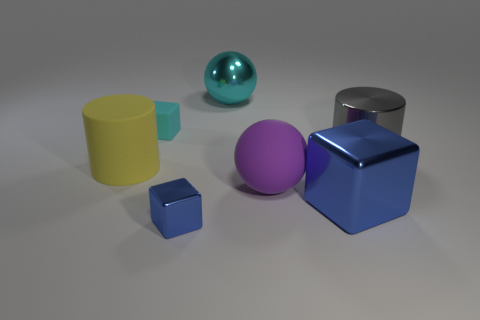What is the shape of the large blue metallic thing?
Your response must be concise. Cube. There is a small blue cube that is in front of the big cylinder that is to the left of the large ball that is on the right side of the big cyan metal object; what is it made of?
Offer a terse response. Metal. Are there more large spheres that are behind the yellow thing than large metallic cylinders?
Offer a terse response. No. What material is the cyan thing that is the same size as the purple sphere?
Offer a terse response. Metal. Are there any cylinders of the same size as the purple ball?
Make the answer very short. Yes. What is the size of the matte object that is behind the gray metallic thing?
Provide a succinct answer. Small. What is the size of the gray thing?
Offer a terse response. Large. How many blocks are tiny gray rubber things or cyan metallic things?
Your answer should be very brief. 0. What is the size of the blue object that is the same material as the big blue cube?
Give a very brief answer. Small. What number of metallic things have the same color as the large shiny block?
Provide a short and direct response. 1. 